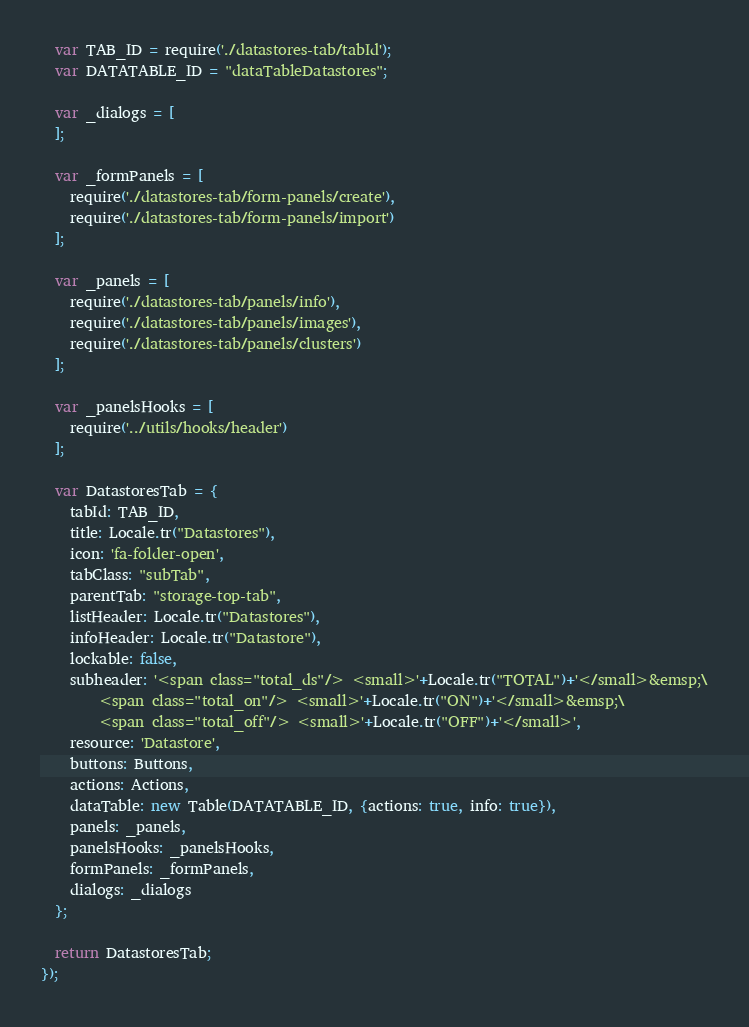<code> <loc_0><loc_0><loc_500><loc_500><_JavaScript_>  var TAB_ID = require('./datastores-tab/tabId');
  var DATATABLE_ID = "dataTableDatastores";

  var _dialogs = [
  ];

  var _formPanels = [
    require('./datastores-tab/form-panels/create'),
    require('./datastores-tab/form-panels/import')
  ];

  var _panels = [
    require('./datastores-tab/panels/info'),
    require('./datastores-tab/panels/images'),
    require('./datastores-tab/panels/clusters')
  ];

  var _panelsHooks = [
    require('../utils/hooks/header')
  ];

  var DatastoresTab = {
    tabId: TAB_ID,
    title: Locale.tr("Datastores"),
    icon: 'fa-folder-open',
    tabClass: "subTab",
    parentTab: "storage-top-tab",
    listHeader: Locale.tr("Datastores"),
    infoHeader: Locale.tr("Datastore"),
    lockable: false,
    subheader: '<span class="total_ds"/> <small>'+Locale.tr("TOTAL")+'</small>&emsp;\
        <span class="total_on"/> <small>'+Locale.tr("ON")+'</small>&emsp;\
        <span class="total_off"/> <small>'+Locale.tr("OFF")+'</small>',
    resource: 'Datastore',
    buttons: Buttons,
    actions: Actions,
    dataTable: new Table(DATATABLE_ID, {actions: true, info: true}),
    panels: _panels,
    panelsHooks: _panelsHooks,
    formPanels: _formPanels,
    dialogs: _dialogs
  };

  return DatastoresTab;
});
</code> 